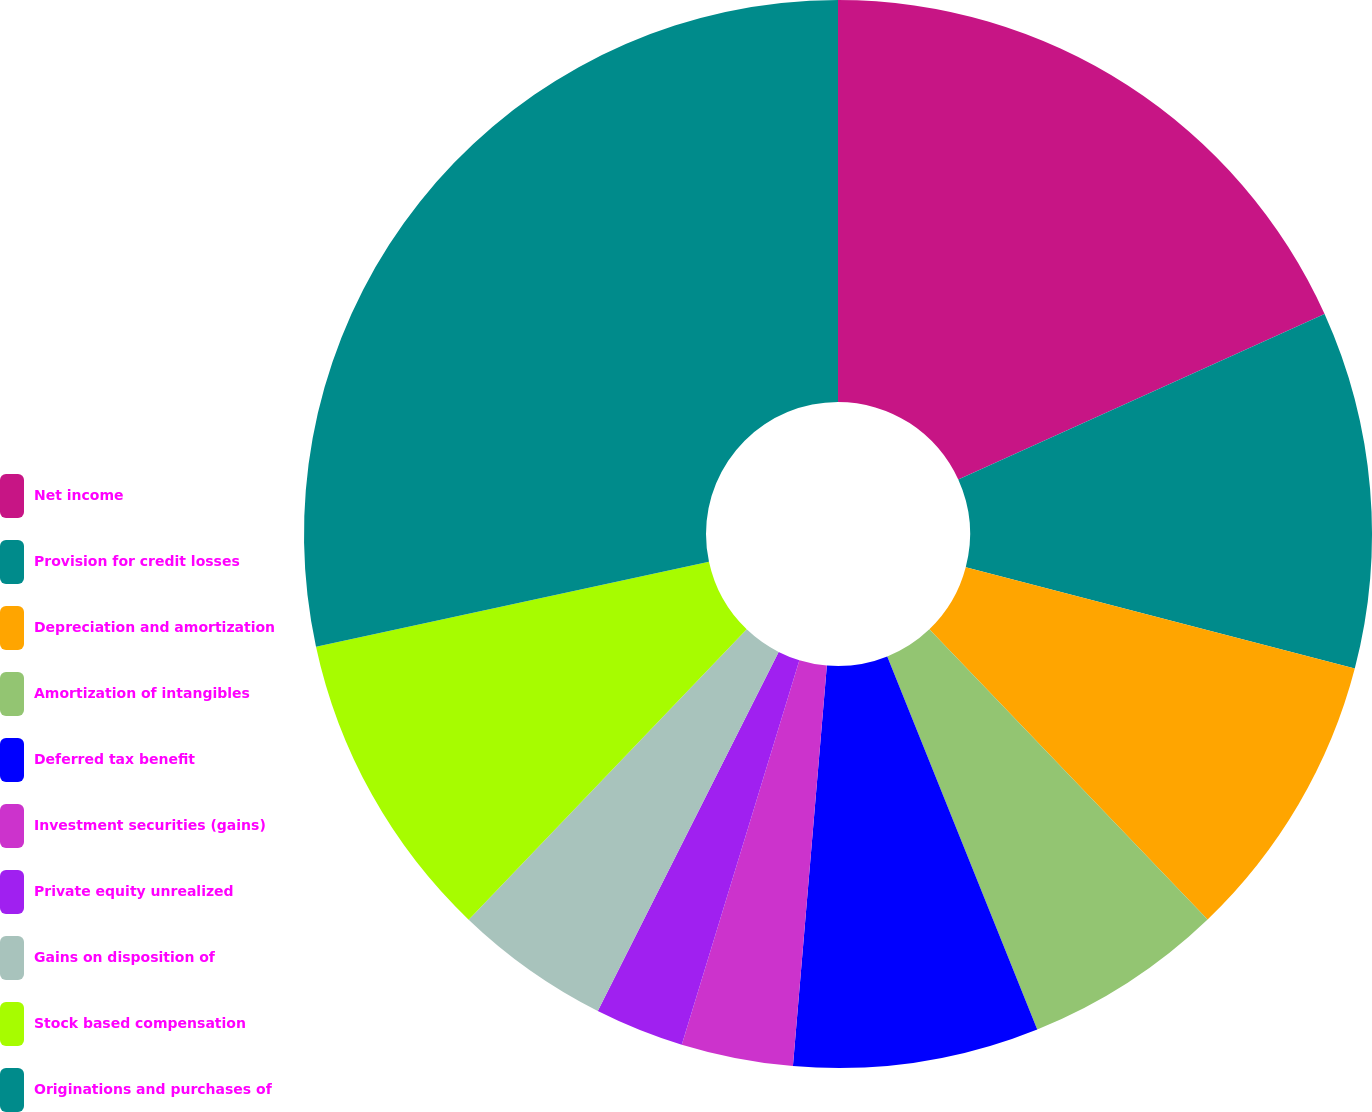<chart> <loc_0><loc_0><loc_500><loc_500><pie_chart><fcel>Net income<fcel>Provision for credit losses<fcel>Depreciation and amortization<fcel>Amortization of intangibles<fcel>Deferred tax benefit<fcel>Investment securities (gains)<fcel>Private equity unrealized<fcel>Gains on disposition of<fcel>Stock based compensation<fcel>Originations and purchases of<nl><fcel>18.24%<fcel>10.81%<fcel>8.78%<fcel>6.08%<fcel>7.43%<fcel>3.38%<fcel>2.7%<fcel>4.73%<fcel>9.46%<fcel>28.38%<nl></chart> 